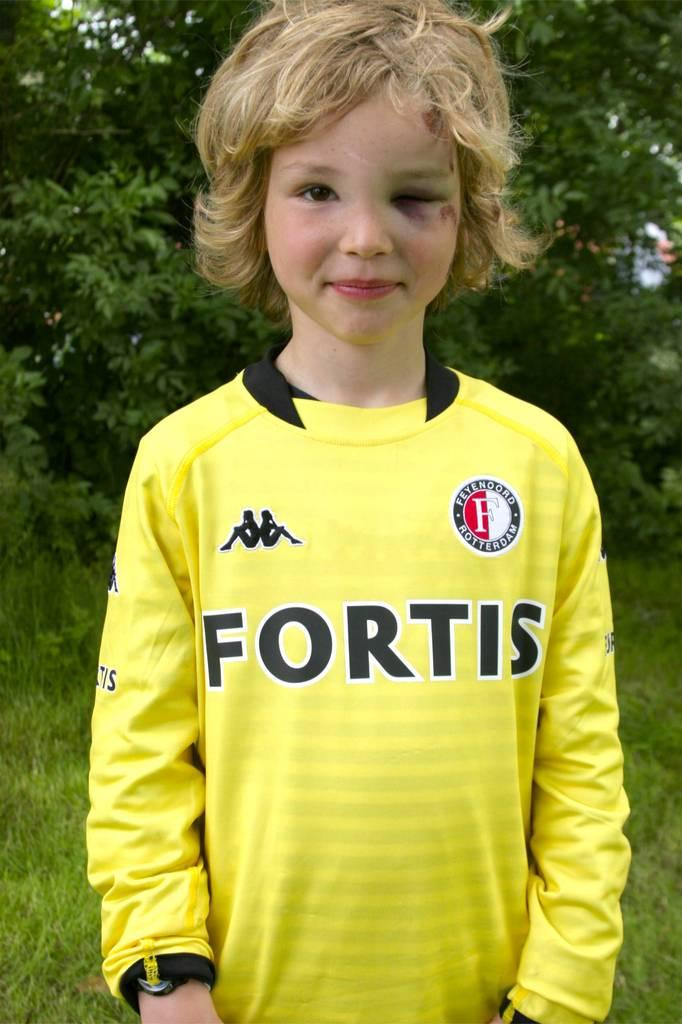What is the main subject in the foreground of the image? There is a picture of a kid in the foreground. What is the kid wearing in the image? The kid is wearing a yellow dress. What is the kid's posture in the image? The kid is standing. What type of vegetation can be seen in the background of the image? There is green grass and plants in the background. What else can be seen in the background of the image? There are other unspecified items in the background. Can you see an airport or airplane in the image? No, there is no airport or airplane present in the image. Is there a bucket visible in the image? No, there is no bucket visible in the image. 